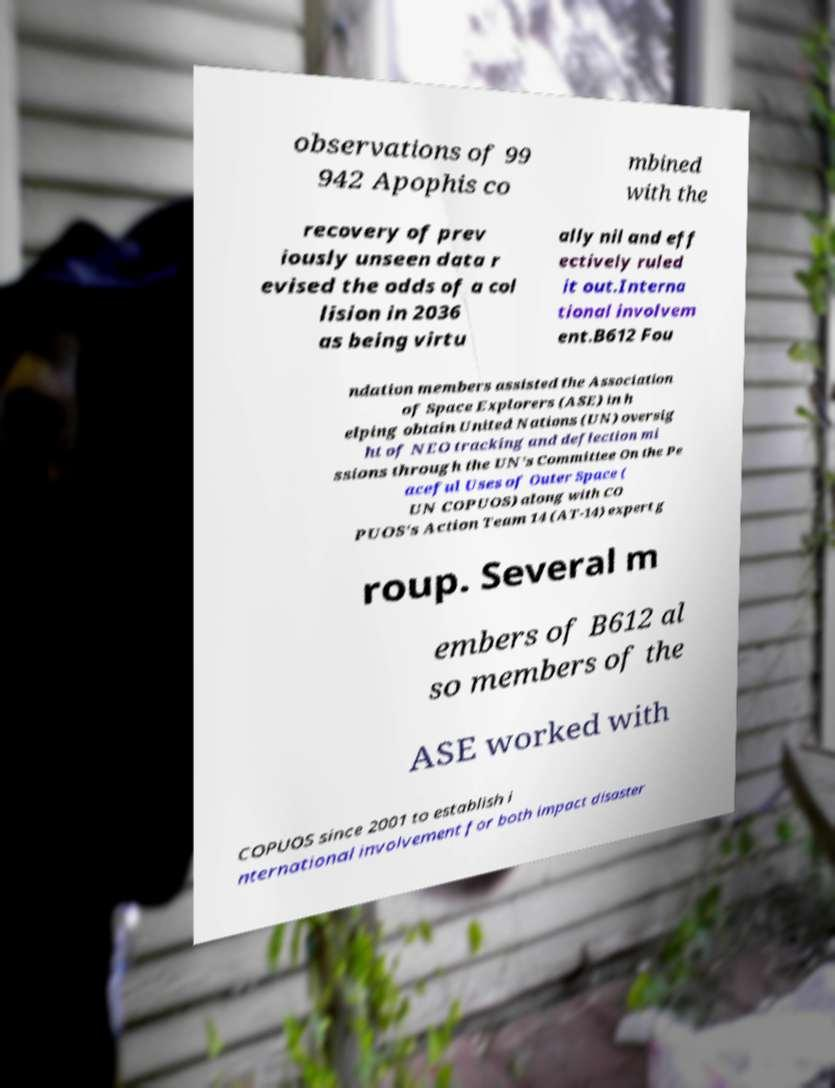Could you assist in decoding the text presented in this image and type it out clearly? observations of 99 942 Apophis co mbined with the recovery of prev iously unseen data r evised the odds of a col lision in 2036 as being virtu ally nil and eff ectively ruled it out.Interna tional involvem ent.B612 Fou ndation members assisted the Association of Space Explorers (ASE) in h elping obtain United Nations (UN) oversig ht of NEO tracking and deflection mi ssions through the UN's Committee On the Pe aceful Uses of Outer Space ( UN COPUOS) along with CO PUOS's Action Team 14 (AT-14) expert g roup. Several m embers of B612 al so members of the ASE worked with COPUOS since 2001 to establish i nternational involvement for both impact disaster 